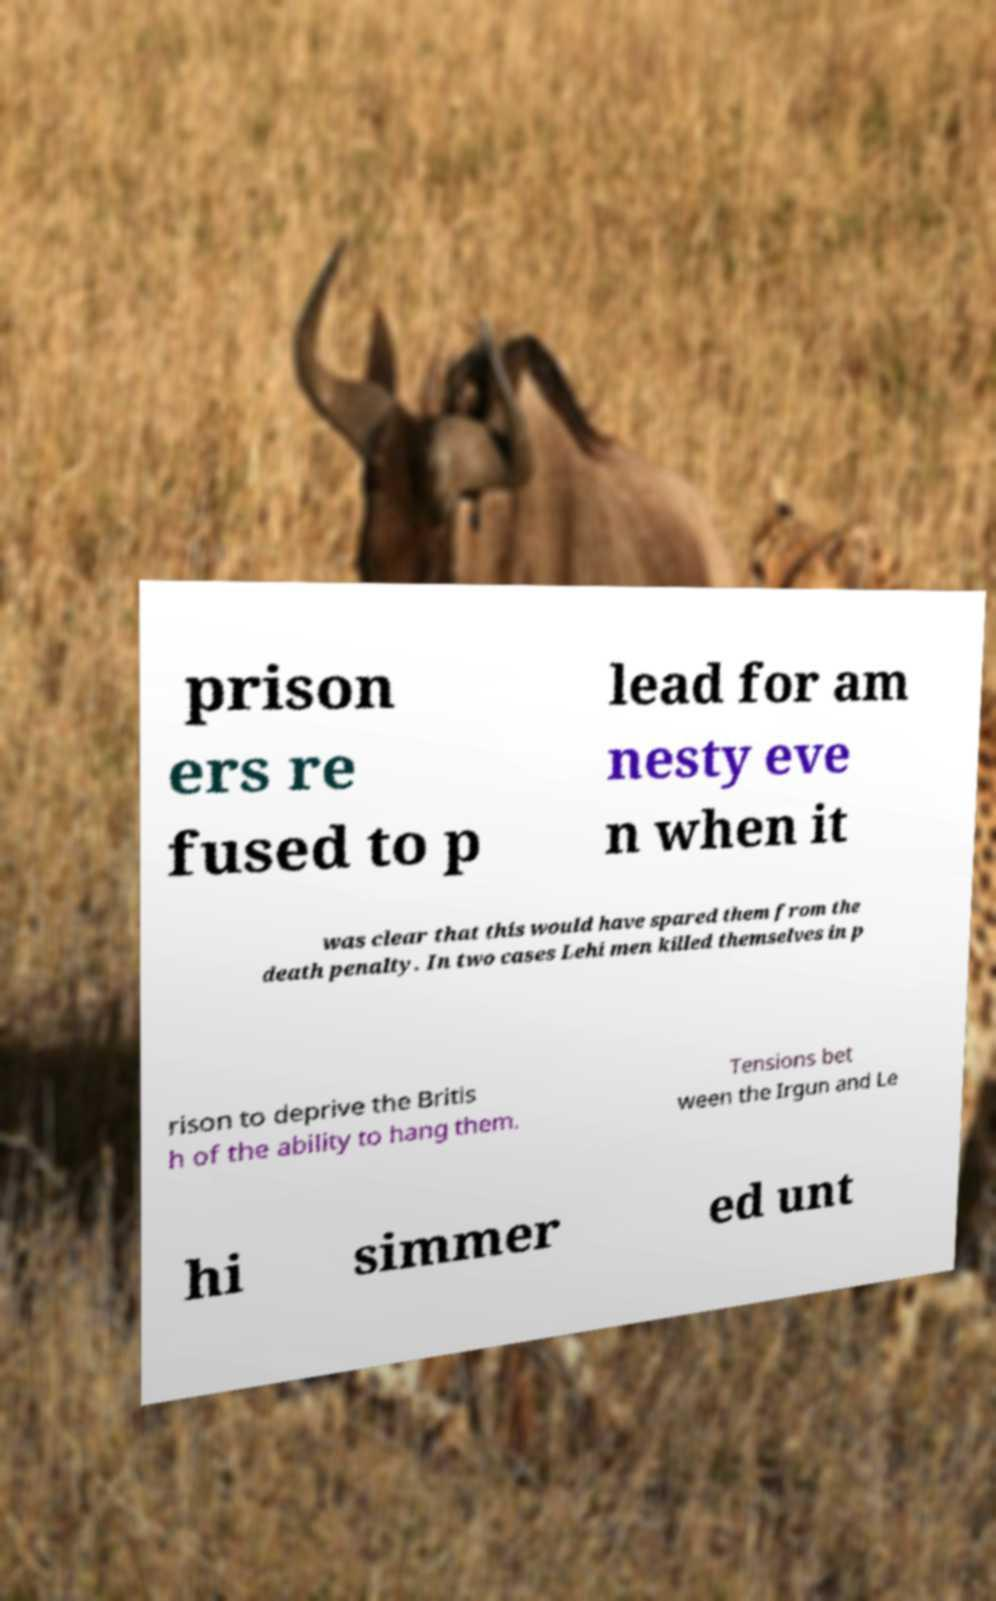I need the written content from this picture converted into text. Can you do that? prison ers re fused to p lead for am nesty eve n when it was clear that this would have spared them from the death penalty. In two cases Lehi men killed themselves in p rison to deprive the Britis h of the ability to hang them. Tensions bet ween the Irgun and Le hi simmer ed unt 